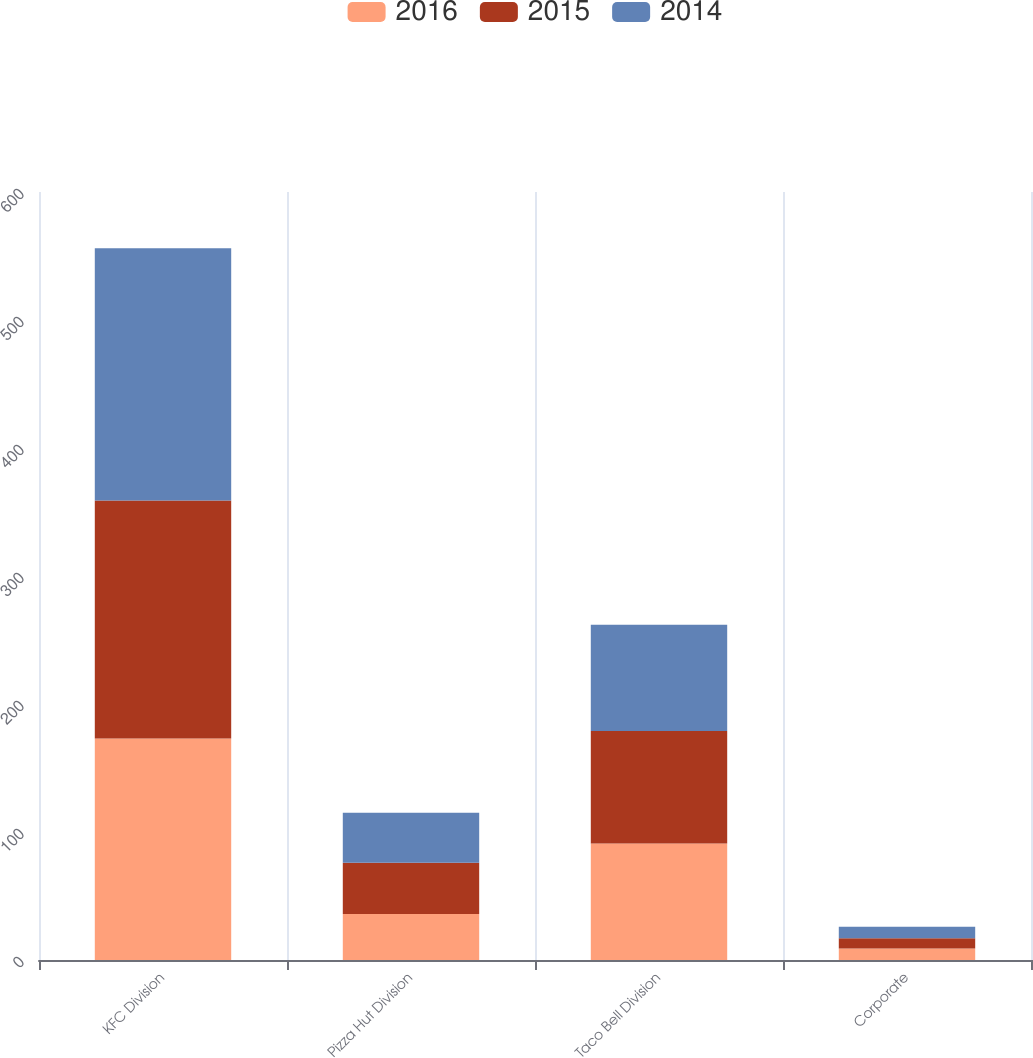Convert chart. <chart><loc_0><loc_0><loc_500><loc_500><stacked_bar_chart><ecel><fcel>KFC Division<fcel>Pizza Hut Division<fcel>Taco Bell Division<fcel>Corporate<nl><fcel>2016<fcel>173<fcel>36<fcel>91<fcel>9<nl><fcel>2015<fcel>186<fcel>40<fcel>88<fcel>8<nl><fcel>2014<fcel>197<fcel>39<fcel>83<fcel>9<nl></chart> 